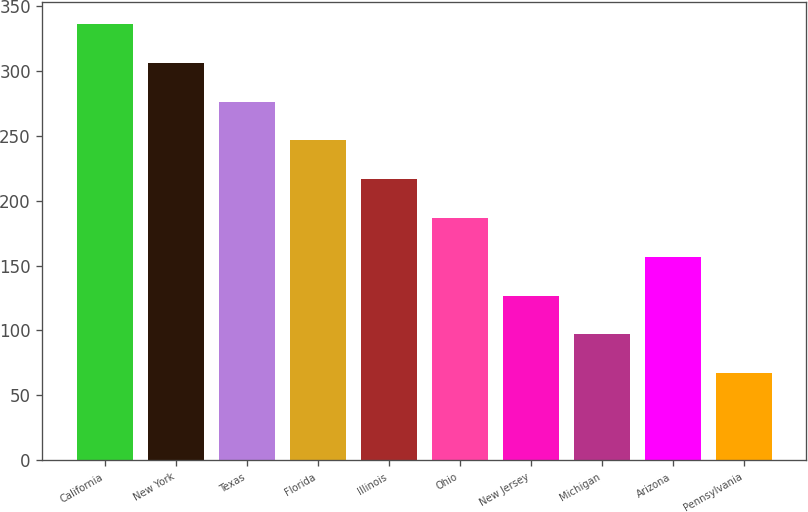Convert chart. <chart><loc_0><loc_0><loc_500><loc_500><bar_chart><fcel>California<fcel>New York<fcel>Texas<fcel>Florida<fcel>Illinois<fcel>Ohio<fcel>New Jersey<fcel>Michigan<fcel>Arizona<fcel>Pennsylvania<nl><fcel>336.22<fcel>306.3<fcel>276.38<fcel>246.46<fcel>216.54<fcel>186.62<fcel>126.78<fcel>96.86<fcel>156.7<fcel>66.94<nl></chart> 